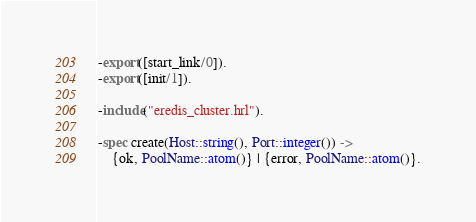<code> <loc_0><loc_0><loc_500><loc_500><_Erlang_>-export([start_link/0]).
-export([init/1]).

-include("eredis_cluster.hrl").

-spec create(Host::string(), Port::integer()) ->
    {ok, PoolName::atom()} | {error, PoolName::atom()}.</code> 